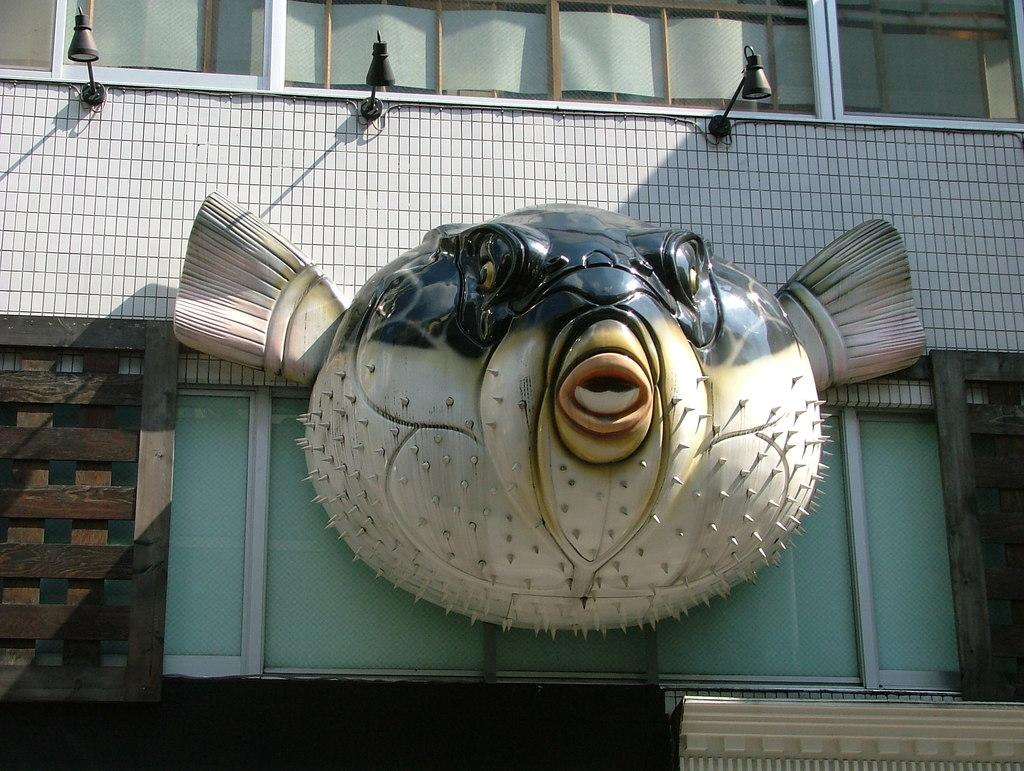What type of structure is present in the image? There is a building in the image. What feature can be seen on the building? The building has windows. What can be seen illuminated in the image? There are lights visible in the image. What type of artwork is present in the image? There is a statue in the image. What else is present in the image besides the building and statue? There are objects in the image. What type of religious ceremony is taking place in the image? There is no indication of a religious ceremony in the image; it features a building, windows, lights, a statue, and other objects. How many chickens are present in the image? There are no chickens present in the image. 